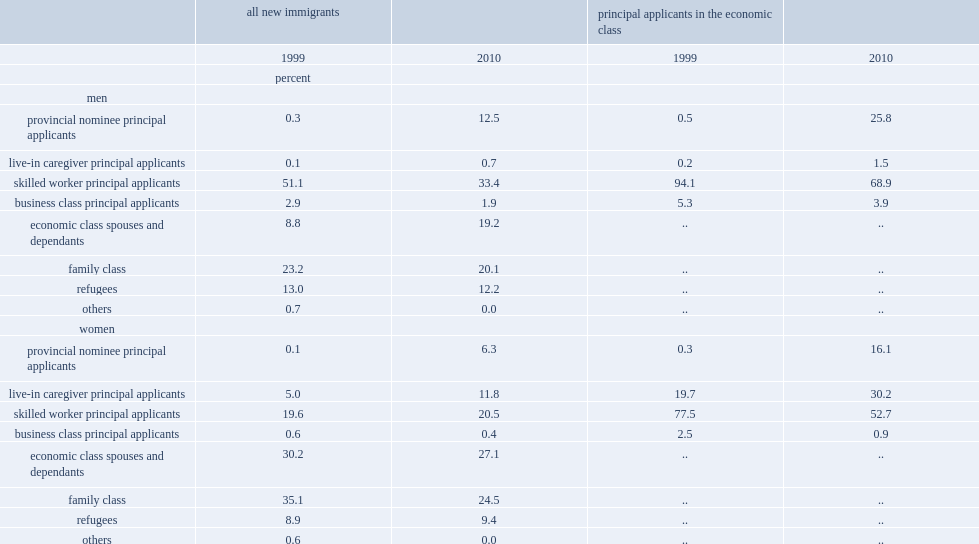What percentage of immigrant men entered as sw pas in 1999 landing cohorts? 51.1. What percentage of immigrant men entered as sw pas in 2010 landing cohorts? 33.4. Which year had a higher share of immigrant men who entered as sw pas, 1999 or 2010? 1999.0. What percentage of immigrant men who entered as pn pas in 1999 landing cohorts? 0.3. What percentage of immigrant men who entered as pn pas in 2010 landing cohorts? 12.5. Which year had a higher share of immigrant men who entered as pn pas, 1999 or 2010? 2010.0. Which year had a higher share of principal immigrants entering under the pnp among men, 1999 or 2010? 2010.0. Which year had a higher share of principal sws among men, 1999 or 2010? 1999.0. What percentage of principal male immigrants entering under the pnp in 1999? 0.5. What percentage of principal male immigrants entering under the pnp in 2010? 25.8. What percentage of principal male immigrants as sws in 1999? 94.1. What percentage of principal male immigrants as sws in 2010? 68.9. 